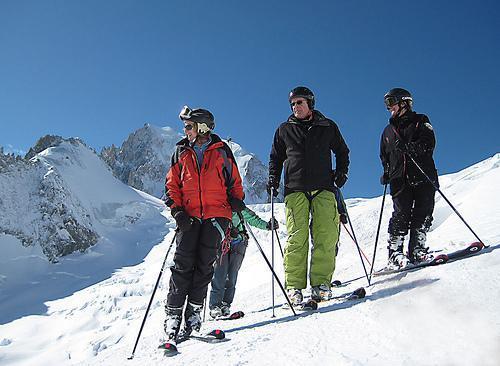How many skiers are shown?
Give a very brief answer. 4. How many of the skiers are adults?
Give a very brief answer. 3. How many children are shown?
Give a very brief answer. 1. 